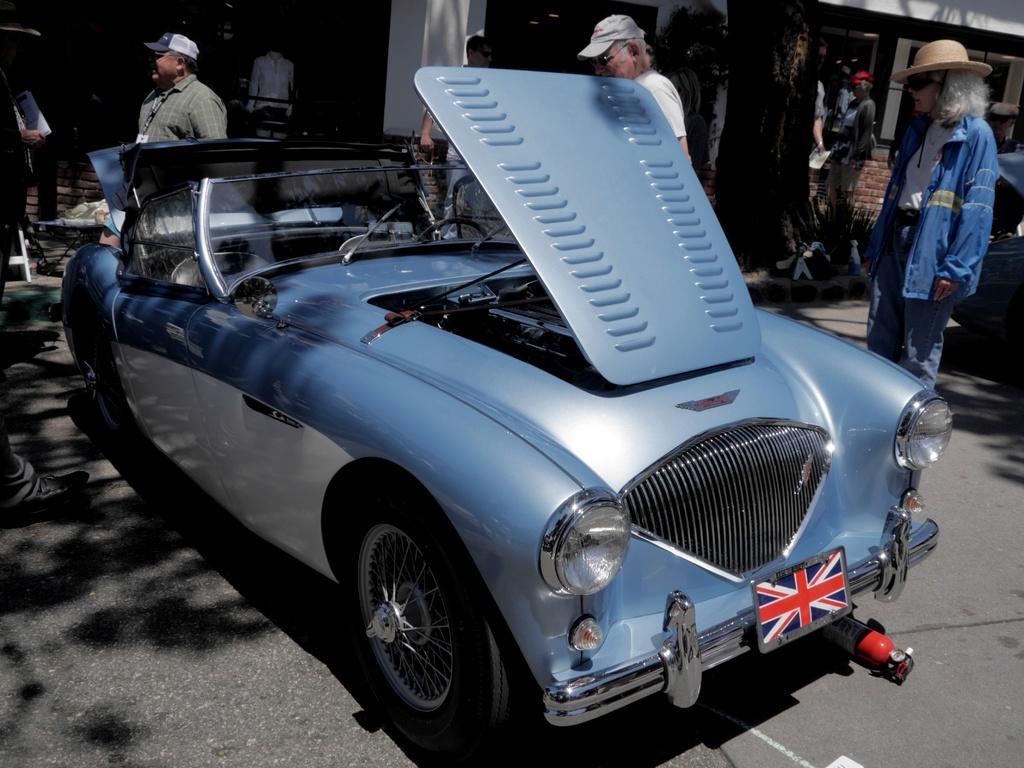Could you give a brief overview of what you see in this image? In the image there is a car with open hood on the road and people walking on either side of it on the road and behind it there is a building. 